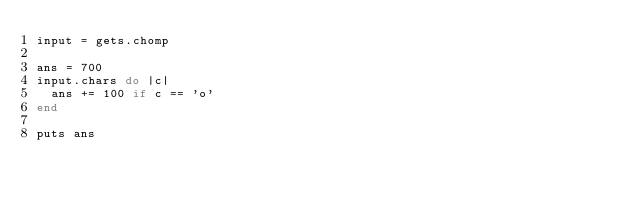Convert code to text. <code><loc_0><loc_0><loc_500><loc_500><_Ruby_>input = gets.chomp

ans = 700
input.chars do |c|
  ans += 100 if c == 'o'
end

puts ans
</code> 